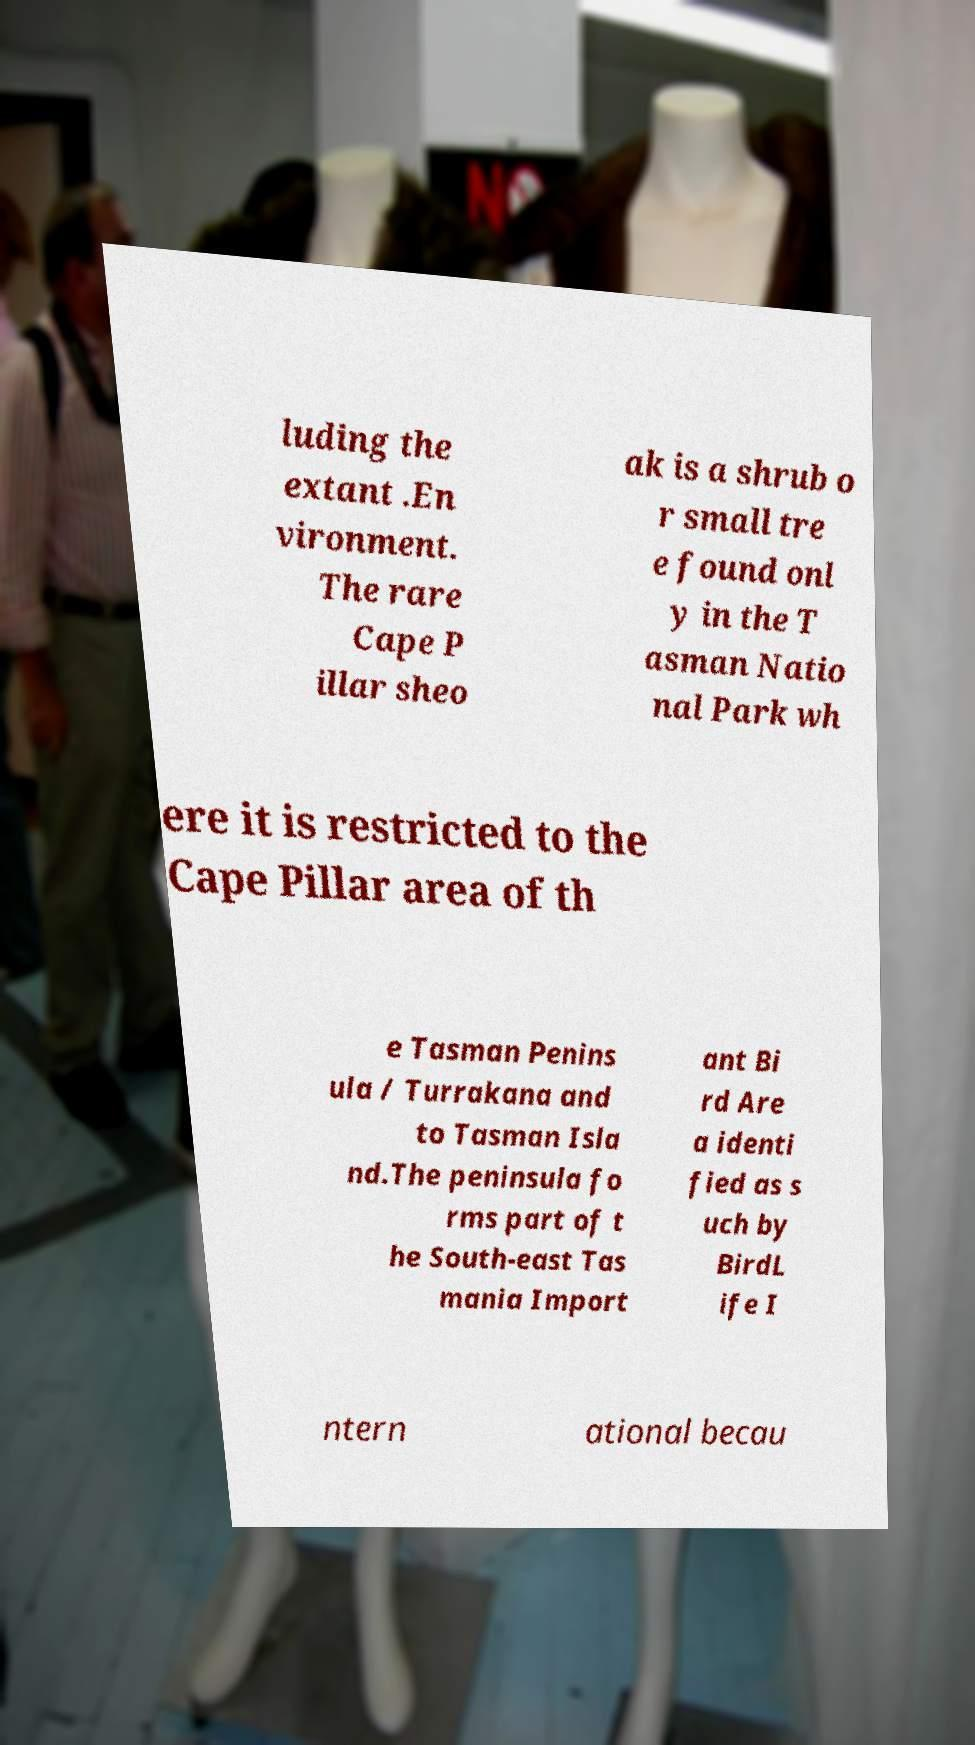There's text embedded in this image that I need extracted. Can you transcribe it verbatim? luding the extant .En vironment. The rare Cape P illar sheo ak is a shrub o r small tre e found onl y in the T asman Natio nal Park wh ere it is restricted to the Cape Pillar area of th e Tasman Penins ula / Turrakana and to Tasman Isla nd.The peninsula fo rms part of t he South-east Tas mania Import ant Bi rd Are a identi fied as s uch by BirdL ife I ntern ational becau 